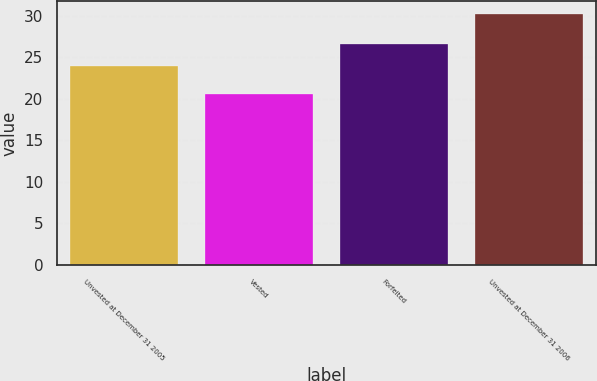Convert chart to OTSL. <chart><loc_0><loc_0><loc_500><loc_500><bar_chart><fcel>Unvested at December 31 2005<fcel>Vested<fcel>Forfeited<fcel>Unvested at December 31 2006<nl><fcel>23.97<fcel>20.59<fcel>26.55<fcel>30.21<nl></chart> 